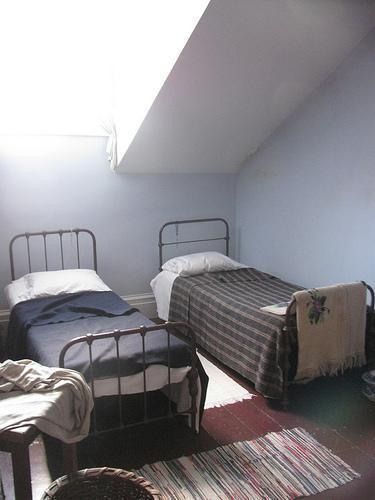How many beds are in the bedroom?
Give a very brief answer. 2. 